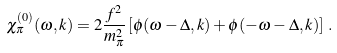Convert formula to latex. <formula><loc_0><loc_0><loc_500><loc_500>\chi _ { \pi } ^ { ( 0 ) } ( \omega , k ) = 2 \frac { f ^ { 2 } } { m _ { \pi } ^ { 2 } } \left [ \phi ( \omega - \Delta , k ) + \phi ( - \omega - \Delta , k ) \right ] \, .</formula> 